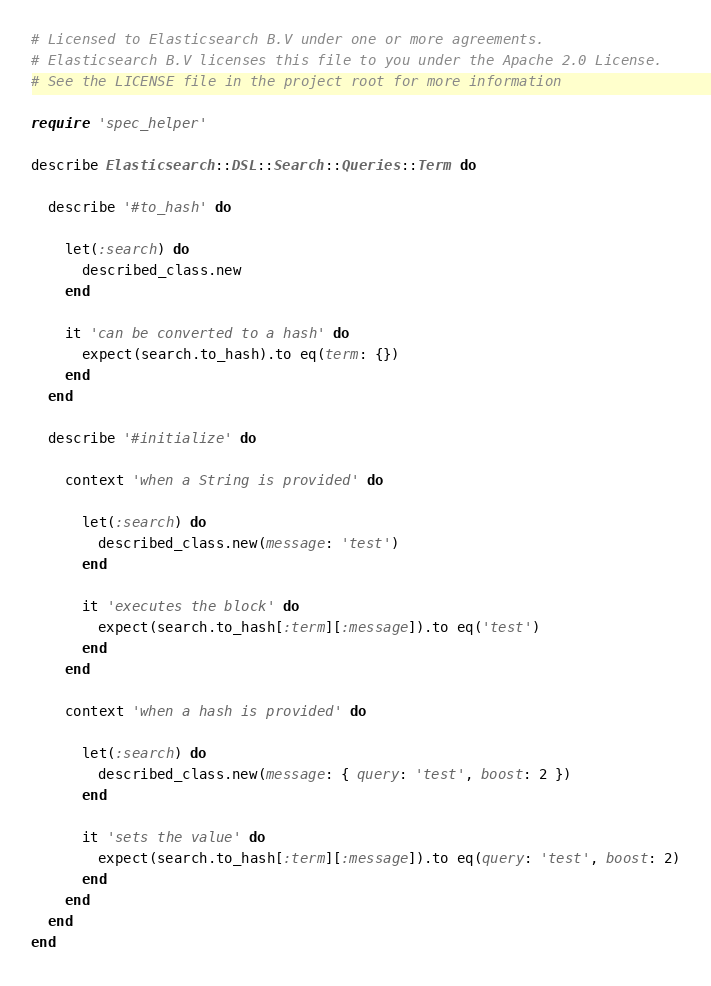Convert code to text. <code><loc_0><loc_0><loc_500><loc_500><_Ruby_># Licensed to Elasticsearch B.V under one or more agreements.
# Elasticsearch B.V licenses this file to you under the Apache 2.0 License.
# See the LICENSE file in the project root for more information

require 'spec_helper'

describe Elasticsearch::DSL::Search::Queries::Term do

  describe '#to_hash' do

    let(:search) do
      described_class.new
    end

    it 'can be converted to a hash' do
      expect(search.to_hash).to eq(term: {})
    end
  end

  describe '#initialize' do

    context 'when a String is provided' do

      let(:search) do
        described_class.new(message: 'test')
      end

      it 'executes the block' do
        expect(search.to_hash[:term][:message]).to eq('test')
      end
    end

    context 'when a hash is provided' do

      let(:search) do
        described_class.new(message: { query: 'test', boost: 2 })
      end

      it 'sets the value' do
        expect(search.to_hash[:term][:message]).to eq(query: 'test', boost: 2)
      end
    end
  end
end
</code> 